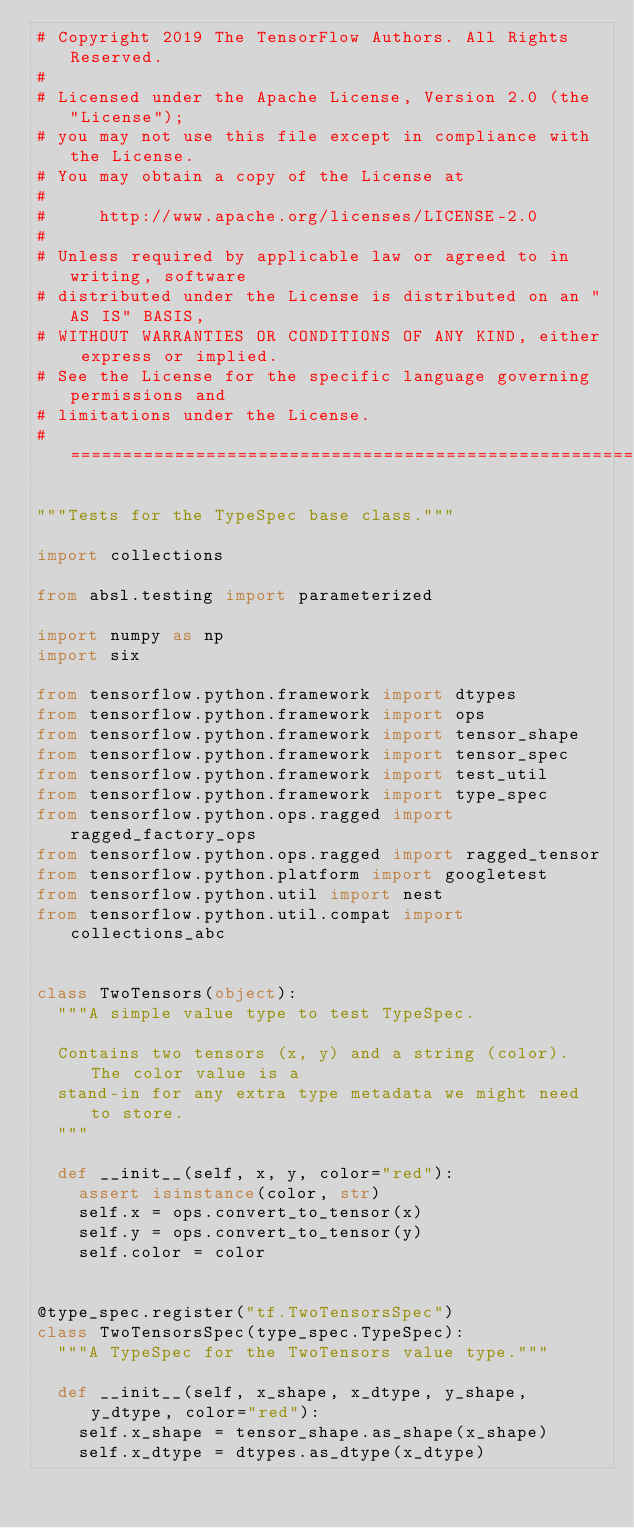<code> <loc_0><loc_0><loc_500><loc_500><_Python_># Copyright 2019 The TensorFlow Authors. All Rights Reserved.
#
# Licensed under the Apache License, Version 2.0 (the "License");
# you may not use this file except in compliance with the License.
# You may obtain a copy of the License at
#
#     http://www.apache.org/licenses/LICENSE-2.0
#
# Unless required by applicable law or agreed to in writing, software
# distributed under the License is distributed on an "AS IS" BASIS,
# WITHOUT WARRANTIES OR CONDITIONS OF ANY KIND, either express or implied.
# See the License for the specific language governing permissions and
# limitations under the License.
# ==============================================================================

"""Tests for the TypeSpec base class."""

import collections

from absl.testing import parameterized

import numpy as np
import six

from tensorflow.python.framework import dtypes
from tensorflow.python.framework import ops
from tensorflow.python.framework import tensor_shape
from tensorflow.python.framework import tensor_spec
from tensorflow.python.framework import test_util
from tensorflow.python.framework import type_spec
from tensorflow.python.ops.ragged import ragged_factory_ops
from tensorflow.python.ops.ragged import ragged_tensor
from tensorflow.python.platform import googletest
from tensorflow.python.util import nest
from tensorflow.python.util.compat import collections_abc


class TwoTensors(object):
  """A simple value type to test TypeSpec.

  Contains two tensors (x, y) and a string (color).  The color value is a
  stand-in for any extra type metadata we might need to store.
  """

  def __init__(self, x, y, color="red"):
    assert isinstance(color, str)
    self.x = ops.convert_to_tensor(x)
    self.y = ops.convert_to_tensor(y)
    self.color = color


@type_spec.register("tf.TwoTensorsSpec")
class TwoTensorsSpec(type_spec.TypeSpec):
  """A TypeSpec for the TwoTensors value type."""

  def __init__(self, x_shape, x_dtype, y_shape, y_dtype, color="red"):
    self.x_shape = tensor_shape.as_shape(x_shape)
    self.x_dtype = dtypes.as_dtype(x_dtype)</code> 